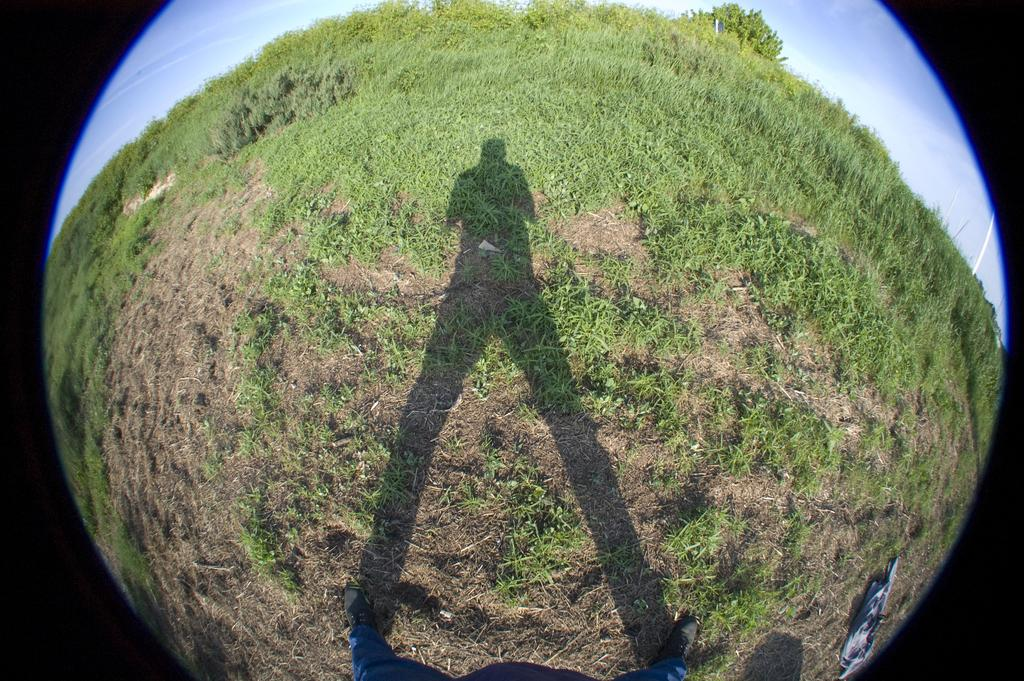What is the shape of the image? The image is convex. What can be seen in the shadow in the image? There is a shadow of a person in the image. What type of vegetation is visible in the image? There is grass visible in the image. What is visible in the background of the image? The sky is visible in the image. What type of prose is being recited by the person's daughter in the image? There is no person's daughter present in the image, and therefore no prose is being recited. 